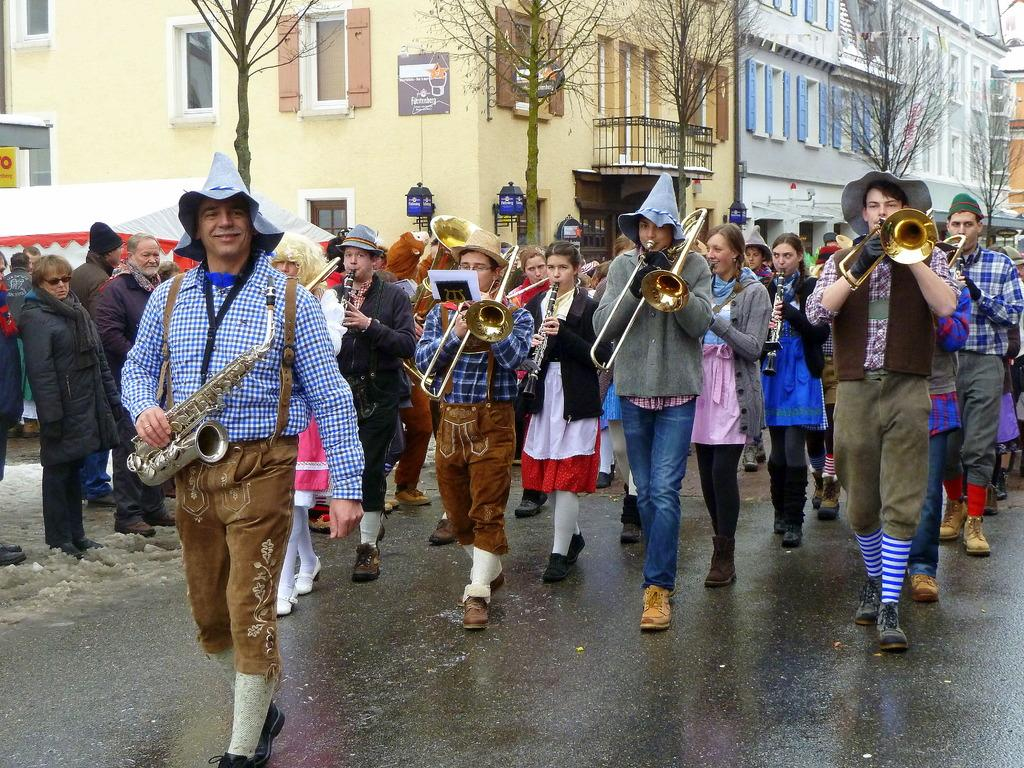How many people are in the group in the image? There is a group of persons in the image, but the exact number is not specified. What are some of the people in the group doing? Some people in the group are playing musical instruments. What can be seen in the background of the image? There are trees, buildings, and a tent visible in the background of the image. What type of haircut does the mailbox have in the image? There is no mailbox present in the image, so it is not possible to determine the type of haircut it might have. 